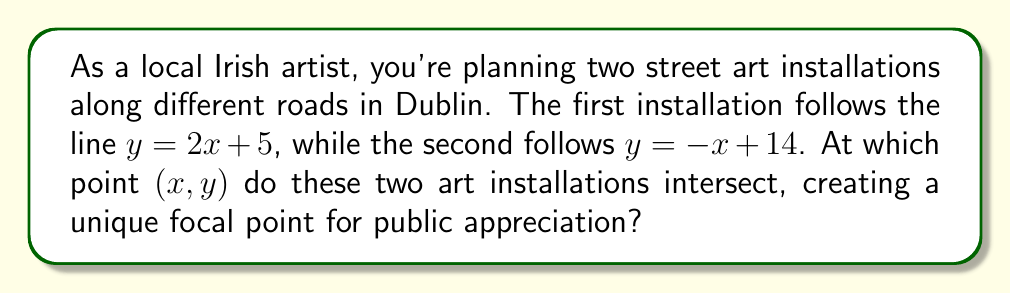Show me your answer to this math problem. To find the intersection point of two lines, we need to solve the system of equations:

$$\begin{cases}
y = 2x + 5 \\
y = -x + 14
\end{cases}$$

Let's solve this step-by-step:

1) Since both equations are equal to $y$, we can set them equal to each other:

   $2x + 5 = -x + 14$

2) Add $x$ to both sides:

   $3x + 5 = 14$

3) Subtract 5 from both sides:

   $3x = 9$

4) Divide both sides by 3:

   $x = 3$

5) Now that we know $x$, we can substitute it into either of the original equations. Let's use the first one:

   $y = 2x + 5$
   $y = 2(3) + 5$
   $y = 6 + 5$
   $y = 11$

Therefore, the intersection point is $(3, 11)$.

[asy]
unitsize(1cm);
defaultpen(fontsize(10pt));

// Draw axes
draw((-1,0)--(5,0), arrow=Arrow(TeXHead));
draw((0,-1)--(0,15), arrow=Arrow(TeXHead));

// Label axes
label("x", (5,0), E);
label("y", (0,15), N);

// Draw lines
draw((0,5)--(4,13), blue, L=Label("y = 2x + 5", position=EndPoint));
draw((0,14)--(5,9), red, L=Label("y = -x + 14", position=EndPoint));

// Mark intersection point
dot((3,11), purple);
label("(3, 11)", (3,11), NE);

// Add some grid lines for reference
for(int i=1; i<=4; ++i) {
  draw((i,0)--(i,15), gray+dashed);
  draw((0,i*3)--(5,i*3), gray+dashed);
}
[/asy]
Answer: The two street art installations intersect at the point $(3, 11)$. 